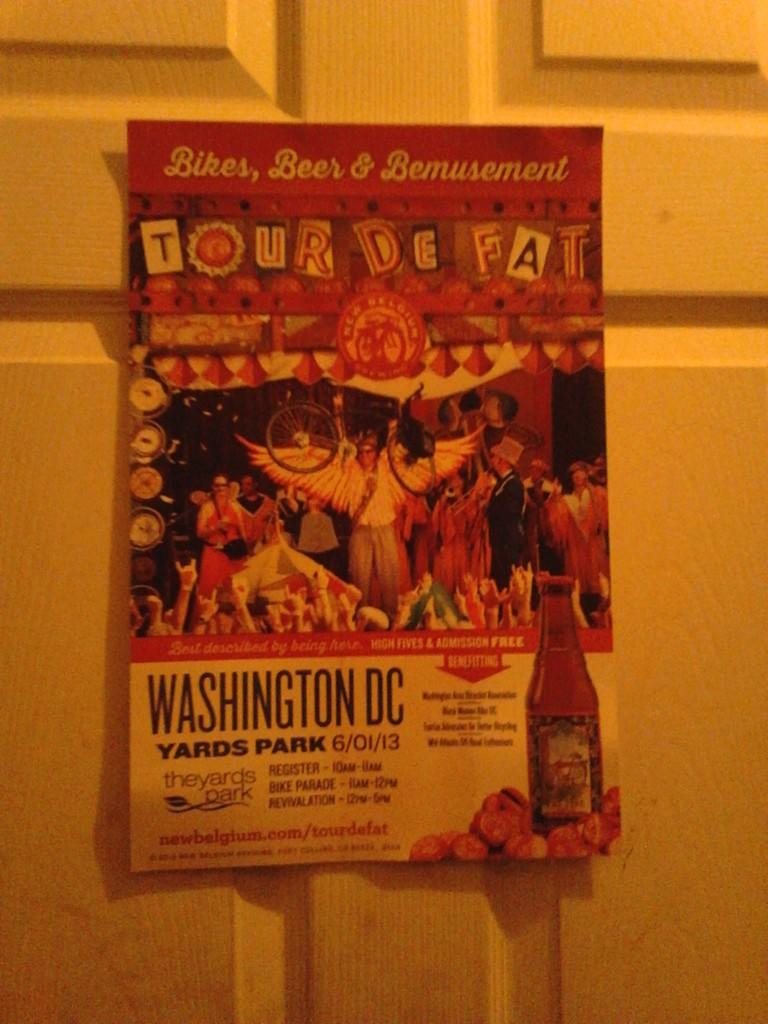<image>
Describe the image concisely. A colorful sign for the Tour De Fat hangs on a door. 